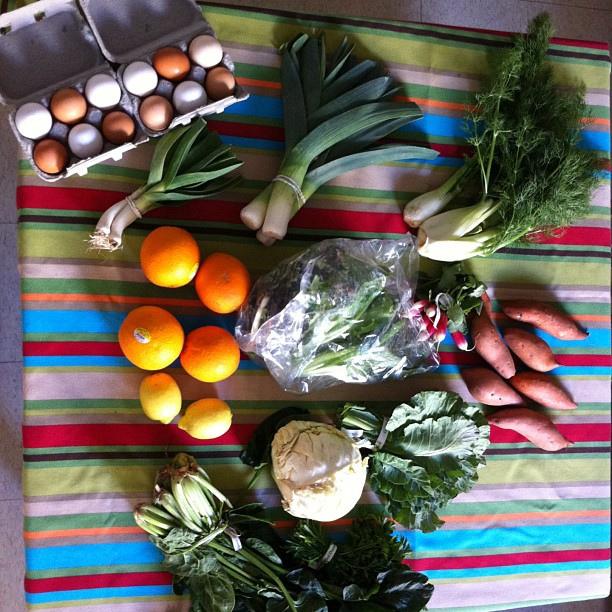How many lemons are there?
Short answer required. 2. Name one stripe color you see on cloth that the veggies are lying on?
Write a very short answer. Blue. How many different food groups are there?
Answer briefly. 3. 